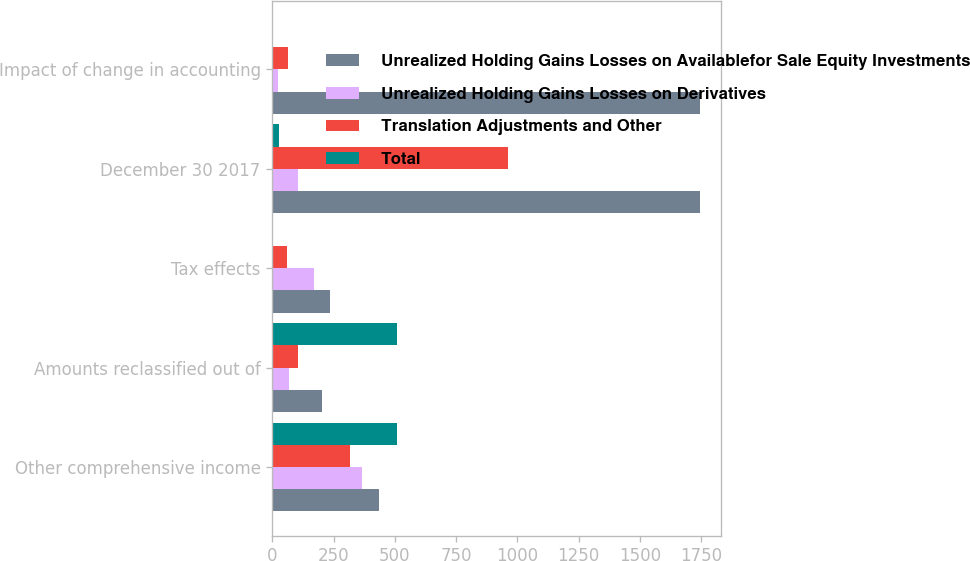<chart> <loc_0><loc_0><loc_500><loc_500><stacked_bar_chart><ecel><fcel>Other comprehensive income<fcel>Amounts reclassified out of<fcel>Tax effects<fcel>December 30 2017<fcel>Impact of change in accounting<nl><fcel>Unrealized Holding Gains Losses on Availablefor Sale Equity Investments<fcel>434<fcel>202.5<fcel>234<fcel>1745<fcel>1745<nl><fcel>Unrealized Holding Gains Losses on Derivatives<fcel>365<fcel>69<fcel>171<fcel>106<fcel>24<nl><fcel>Translation Adjustments and Other<fcel>317<fcel>103<fcel>61<fcel>963<fcel>65<nl><fcel>Total<fcel>508<fcel>509<fcel>1<fcel>26<fcel>4<nl></chart> 